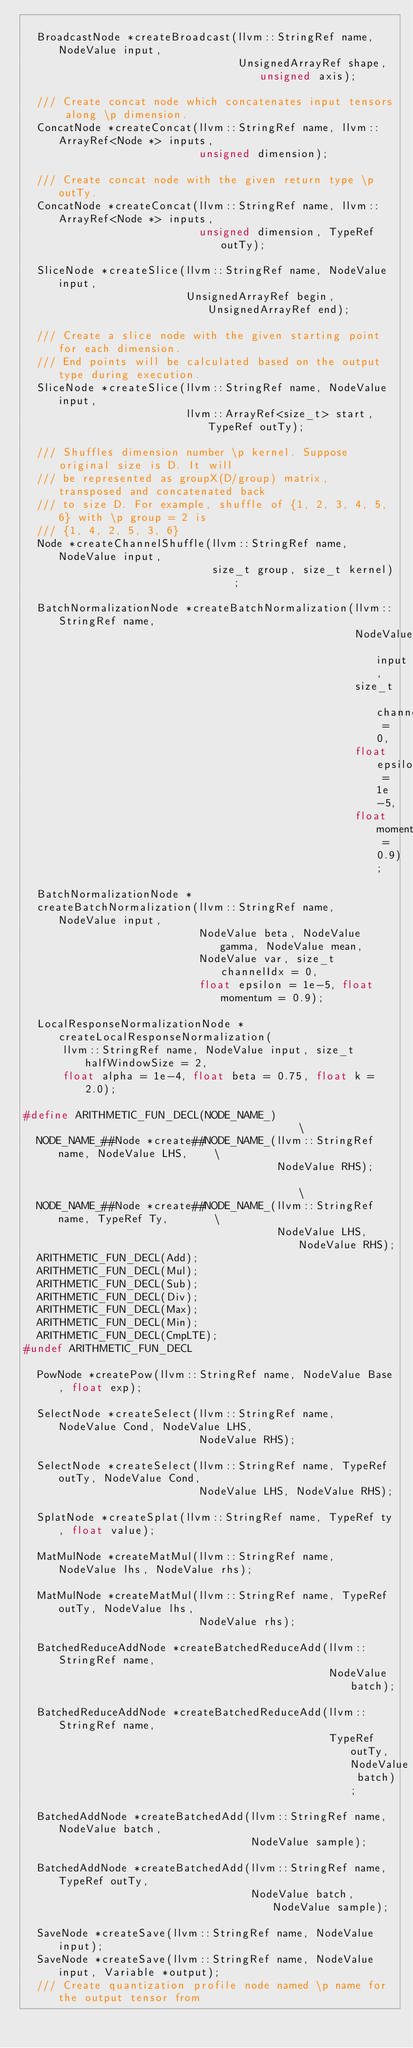<code> <loc_0><loc_0><loc_500><loc_500><_C_>
  BroadcastNode *createBroadcast(llvm::StringRef name, NodeValue input,
                                 UnsignedArrayRef shape, unsigned axis);

  /// Create concat node which concatenates input tensors along \p dimension.
  ConcatNode *createConcat(llvm::StringRef name, llvm::ArrayRef<Node *> inputs,
                           unsigned dimension);

  /// Create concat node with the given return type \p outTy.
  ConcatNode *createConcat(llvm::StringRef name, llvm::ArrayRef<Node *> inputs,
                           unsigned dimension, TypeRef outTy);

  SliceNode *createSlice(llvm::StringRef name, NodeValue input,
                         UnsignedArrayRef begin, UnsignedArrayRef end);

  /// Create a slice node with the given starting point for each dimension.
  /// End points will be calculated based on the output type during execution.
  SliceNode *createSlice(llvm::StringRef name, NodeValue input,
                         llvm::ArrayRef<size_t> start, TypeRef outTy);

  /// Shuffles dimension number \p kernel. Suppose original size is D. It will
  /// be represented as groupX(D/group) matrix, transposed and concatenated back
  /// to size D. For example, shuffle of {1, 2, 3, 4, 5, 6} with \p group = 2 is
  /// {1, 4, 2, 5, 3, 6}
  Node *createChannelShuffle(llvm::StringRef name, NodeValue input,
                             size_t group, size_t kernel);

  BatchNormalizationNode *createBatchNormalization(llvm::StringRef name,
                                                   NodeValue input,
                                                   size_t channelIdx = 0,
                                                   float epsilon = 1e-5,
                                                   float momentum = 0.9);

  BatchNormalizationNode *
  createBatchNormalization(llvm::StringRef name, NodeValue input,
                           NodeValue beta, NodeValue gamma, NodeValue mean,
                           NodeValue var, size_t channelIdx = 0,
                           float epsilon = 1e-5, float momentum = 0.9);

  LocalResponseNormalizationNode *createLocalResponseNormalization(
      llvm::StringRef name, NodeValue input, size_t halfWindowSize = 2,
      float alpha = 1e-4, float beta = 0.75, float k = 2.0);

#define ARITHMETIC_FUN_DECL(NODE_NAME_)                                        \
  NODE_NAME_##Node *create##NODE_NAME_(llvm::StringRef name, NodeValue LHS,    \
                                       NodeValue RHS);                         \
  NODE_NAME_##Node *create##NODE_NAME_(llvm::StringRef name, TypeRef Ty,       \
                                       NodeValue LHS, NodeValue RHS);
  ARITHMETIC_FUN_DECL(Add);
  ARITHMETIC_FUN_DECL(Mul);
  ARITHMETIC_FUN_DECL(Sub);
  ARITHMETIC_FUN_DECL(Div);
  ARITHMETIC_FUN_DECL(Max);
  ARITHMETIC_FUN_DECL(Min);
  ARITHMETIC_FUN_DECL(CmpLTE);
#undef ARITHMETIC_FUN_DECL

  PowNode *createPow(llvm::StringRef name, NodeValue Base, float exp);

  SelectNode *createSelect(llvm::StringRef name, NodeValue Cond, NodeValue LHS,
                           NodeValue RHS);

  SelectNode *createSelect(llvm::StringRef name, TypeRef outTy, NodeValue Cond,
                           NodeValue LHS, NodeValue RHS);

  SplatNode *createSplat(llvm::StringRef name, TypeRef ty, float value);

  MatMulNode *createMatMul(llvm::StringRef name, NodeValue lhs, NodeValue rhs);

  MatMulNode *createMatMul(llvm::StringRef name, TypeRef outTy, NodeValue lhs,
                           NodeValue rhs);

  BatchedReduceAddNode *createBatchedReduceAdd(llvm::StringRef name,
                                               NodeValue batch);

  BatchedReduceAddNode *createBatchedReduceAdd(llvm::StringRef name,
                                               TypeRef outTy, NodeValue batch);

  BatchedAddNode *createBatchedAdd(llvm::StringRef name, NodeValue batch,
                                   NodeValue sample);

  BatchedAddNode *createBatchedAdd(llvm::StringRef name, TypeRef outTy,
                                   NodeValue batch, NodeValue sample);

  SaveNode *createSave(llvm::StringRef name, NodeValue input);
  SaveNode *createSave(llvm::StringRef name, NodeValue input, Variable *output);
  /// Create quantization profile node named \p name for the output tensor from</code> 